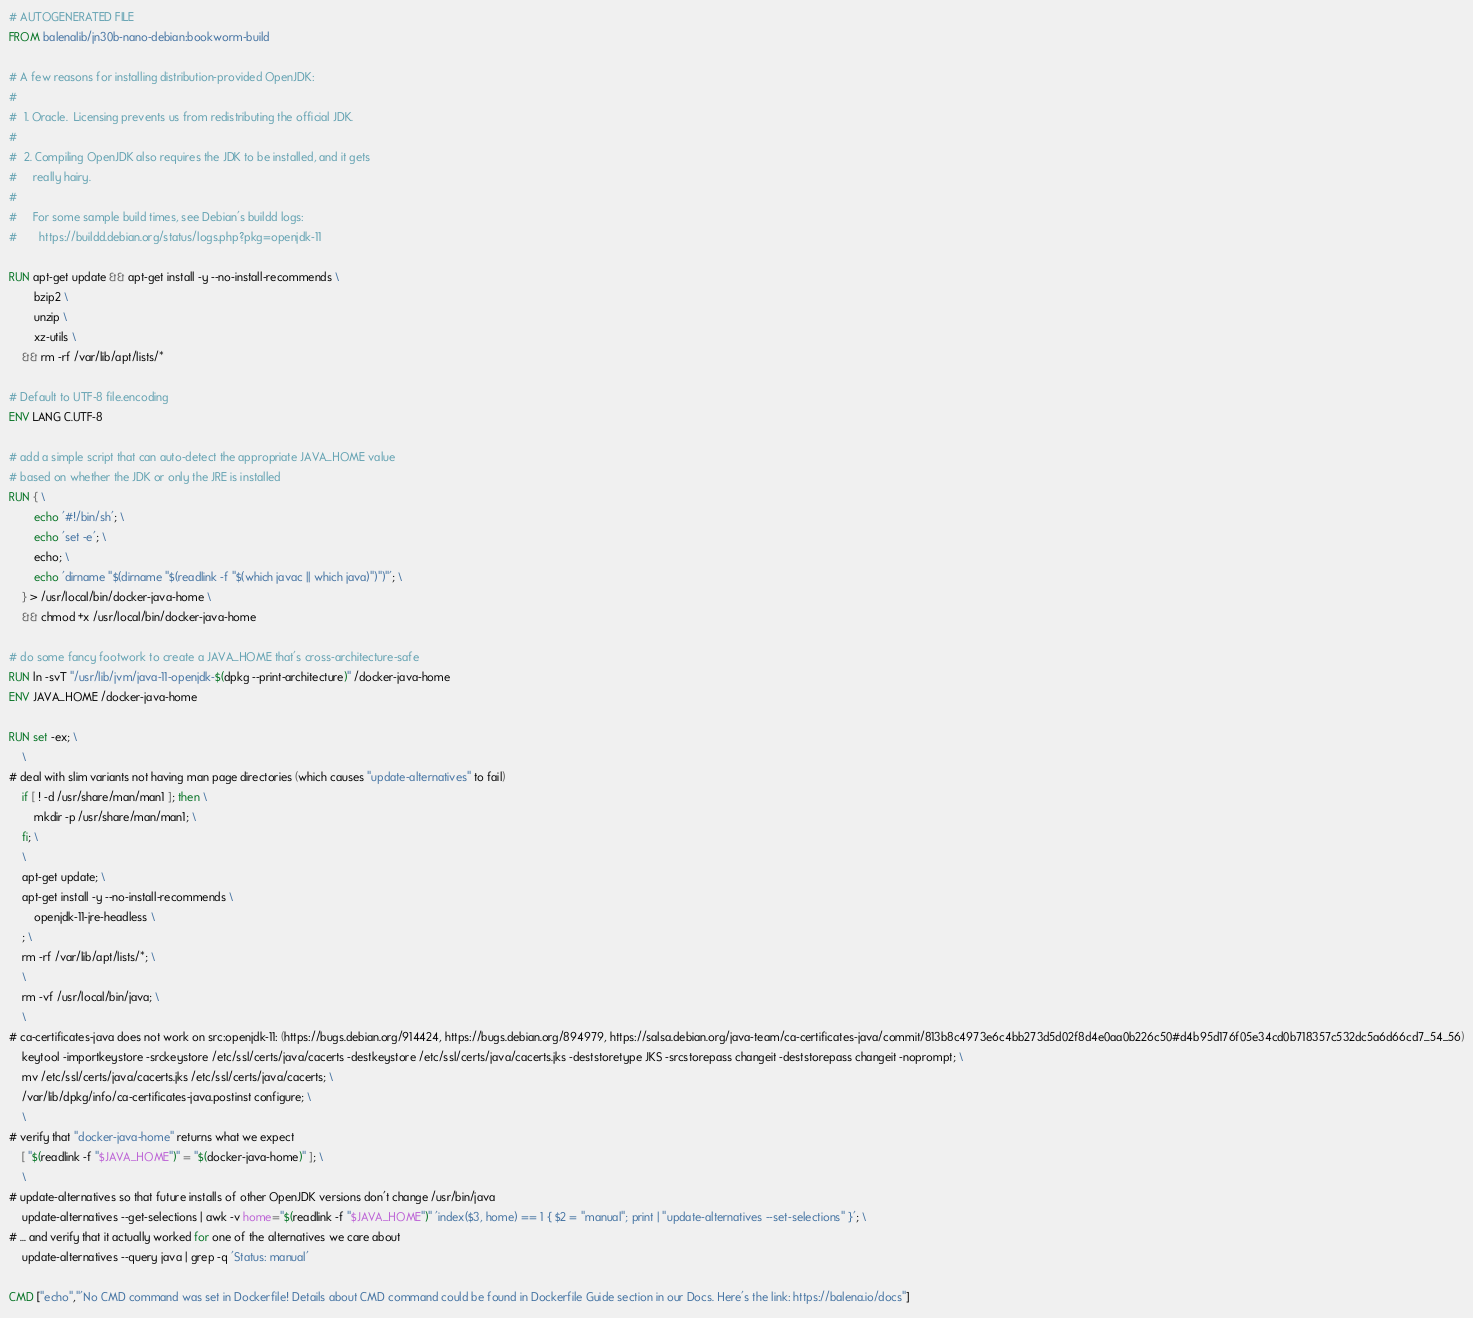Convert code to text. <code><loc_0><loc_0><loc_500><loc_500><_Dockerfile_># AUTOGENERATED FILE
FROM balenalib/jn30b-nano-debian:bookworm-build

# A few reasons for installing distribution-provided OpenJDK:
#
#  1. Oracle.  Licensing prevents us from redistributing the official JDK.
#
#  2. Compiling OpenJDK also requires the JDK to be installed, and it gets
#     really hairy.
#
#     For some sample build times, see Debian's buildd logs:
#       https://buildd.debian.org/status/logs.php?pkg=openjdk-11

RUN apt-get update && apt-get install -y --no-install-recommends \
		bzip2 \
		unzip \
		xz-utils \
	&& rm -rf /var/lib/apt/lists/*

# Default to UTF-8 file.encoding
ENV LANG C.UTF-8

# add a simple script that can auto-detect the appropriate JAVA_HOME value
# based on whether the JDK or only the JRE is installed
RUN { \
		echo '#!/bin/sh'; \
		echo 'set -e'; \
		echo; \
		echo 'dirname "$(dirname "$(readlink -f "$(which javac || which java)")")"'; \
	} > /usr/local/bin/docker-java-home \
	&& chmod +x /usr/local/bin/docker-java-home

# do some fancy footwork to create a JAVA_HOME that's cross-architecture-safe
RUN ln -svT "/usr/lib/jvm/java-11-openjdk-$(dpkg --print-architecture)" /docker-java-home
ENV JAVA_HOME /docker-java-home

RUN set -ex; \
	\
# deal with slim variants not having man page directories (which causes "update-alternatives" to fail)
	if [ ! -d /usr/share/man/man1 ]; then \
		mkdir -p /usr/share/man/man1; \
	fi; \
	\
	apt-get update; \
	apt-get install -y --no-install-recommends \
		openjdk-11-jre-headless \
	; \
	rm -rf /var/lib/apt/lists/*; \
	\
	rm -vf /usr/local/bin/java; \
	\
# ca-certificates-java does not work on src:openjdk-11: (https://bugs.debian.org/914424, https://bugs.debian.org/894979, https://salsa.debian.org/java-team/ca-certificates-java/commit/813b8c4973e6c4bb273d5d02f8d4e0aa0b226c50#d4b95d176f05e34cd0b718357c532dc5a6d66cd7_54_56)
	keytool -importkeystore -srckeystore /etc/ssl/certs/java/cacerts -destkeystore /etc/ssl/certs/java/cacerts.jks -deststoretype JKS -srcstorepass changeit -deststorepass changeit -noprompt; \
	mv /etc/ssl/certs/java/cacerts.jks /etc/ssl/certs/java/cacerts; \
	/var/lib/dpkg/info/ca-certificates-java.postinst configure; \
	\
# verify that "docker-java-home" returns what we expect
	[ "$(readlink -f "$JAVA_HOME")" = "$(docker-java-home)" ]; \
	\
# update-alternatives so that future installs of other OpenJDK versions don't change /usr/bin/java
	update-alternatives --get-selections | awk -v home="$(readlink -f "$JAVA_HOME")" 'index($3, home) == 1 { $2 = "manual"; print | "update-alternatives --set-selections" }'; \
# ... and verify that it actually worked for one of the alternatives we care about
	update-alternatives --query java | grep -q 'Status: manual'

CMD ["echo","'No CMD command was set in Dockerfile! Details about CMD command could be found in Dockerfile Guide section in our Docs. Here's the link: https://balena.io/docs"]
</code> 